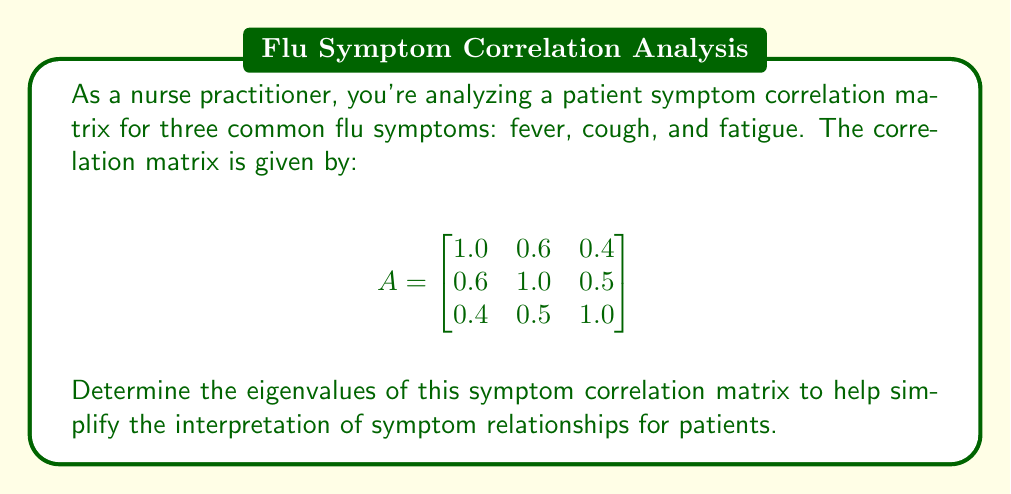Could you help me with this problem? To find the eigenvalues of the correlation matrix A, we need to solve the characteristic equation:

$$ \det(A - \lambda I) = 0 $$

where $\lambda$ represents the eigenvalues and I is the 3x3 identity matrix.

Step 1: Set up the characteristic equation:
$$ \det\begin{pmatrix}
1.0 - \lambda & 0.6 & 0.4 \\
0.6 & 1.0 - \lambda & 0.5 \\
0.4 & 0.5 & 1.0 - \lambda
\end{pmatrix} = 0 $$

Step 2: Expand the determinant:
$$ (1-\lambda)[(1-\lambda)(1-\lambda) - 0.25] - 0.6[0.6(1-\lambda) - 0.2] + 0.4[0.3 - 0.5(1-\lambda)] = 0 $$

Step 3: Simplify the equation:
$$ (1-\lambda)[(1-\lambda)^2 - 0.25] - 0.6[0.6 - 0.6\lambda - 0.2] + 0.4[0.3 - 0.5 + 0.5\lambda] = 0 $$
$$ (1-\lambda)[(1-\lambda)^2 - 0.25] - 0.6[0.4 - 0.6\lambda] + 0.4[-0.2 + 0.5\lambda] = 0 $$
$$ (1-\lambda)^3 - 0.25(1-\lambda) - 0.24 + 0.36\lambda - 0.08 + 0.2\lambda = 0 $$
$$ (1-\lambda)^3 - 0.25 + 0.25\lambda - 0.32 + 0.56\lambda = 0 $$
$$ (1-\lambda)^3 + 0.81\lambda - 0.57 = 0 $$

Step 4: Expand the cubic term:
$$ 1 - 3\lambda + 3\lambda^2 - \lambda^3 + 0.81\lambda - 0.57 = 0 $$
$$ -\lambda^3 + 3\lambda^2 - 2.19\lambda + 0.43 = 0 $$

Step 5: Solve the cubic equation. The roots of this equation are the eigenvalues. Using a numerical method or computer algebra system, we find the roots:

$$ \lambda_1 \approx 2.0583 $$
$$ \lambda_2 \approx 0.6194 $$
$$ \lambda_3 \approx 0.3223 $$
Answer: $\lambda_1 \approx 2.0583$, $\lambda_2 \approx 0.6194$, $\lambda_3 \approx 0.3223$ 